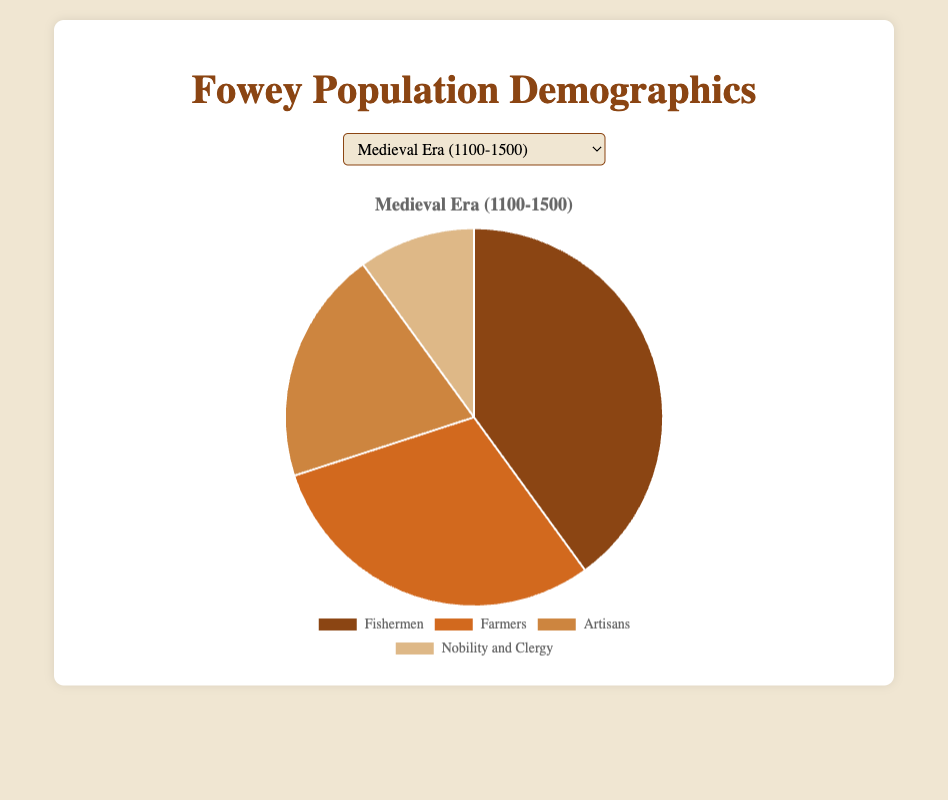What percentage of Fowey's population was involved in fishing during the Medieval Era? To find the percentage of the population involved in fishing during the Medieval Era, simply refer to the pie chart and locate the segment labeled "Fishermen."
Answer: 40% Which group saw the largest increase in population share from the Medieval Era to the Tudor Period? To determine the group with the largest increase in population share, compare the percentages of each demographic from the Medieval Era and the Tudor Period and identify the group with the greatest positive change.
Answer: Farmers What is the combined percentage of population involved in agriculture during the Tudor Period and Industrial Revolution? Add the percentage of Farmers from the Tudor Period (35%) and the Industrial Revolution (20%) to get the combined share.
Answer: 55% Which period had the highest percentage of the population working in the service sector? Look at the segments related to "Service Industry" or "Service Workers" across all periods and identify the one with the largest percentage.
Answer: Modern Period In the Modern Period, what is the total percentage of the population involved in either Tourism or Education and Public Services? Add the percentages for "Tourism" (30%) and "Education and Public Services" (10%) to get the total percentage.
Answer: 40% Compare the percentage of "Merchants" during the Industrial Revolution to the percentage of "Retirees" in the Modern Period. Which is greater? Look at the pie charts for the Industrial Revolution and Modern Period, identify the percentages for "Merchants" (15%) and "Retirees" (20%) respectively, and compare them.
Answer: Retirees What was the least common occupation during the Medieval Era? Identify the segment with the smallest percentage in the pie chart for the Medieval Era, which is "Nobility and Clergy" at 10%.
Answer: Nobility and Clergy How does the percentage of "Fishermen" in the Tudor Period compare to that in the Medieval Era? Look at both periods' charts, noting the percentages for "Fishermen" in the Medieval Era (40%) and Tudor Period (25%), and then compare them.
Answer: Decreased Which demographic forms exactly half of the population in the Industrial Revolution period? Look for the segment that occupies 50% of the chart in the Industrial Revolution period, which is "Industrial Workers."
Answer: Industrial Workers What's the difference in the percentage of the population involved in the service sector between the Industrial Revolution and Modern Period? Subtract the percentage of "Service Workers" (15%) during the Industrial Revolution from the percentage of "Service Industry" (40%) in the Modern Period.
Answer: 25% 